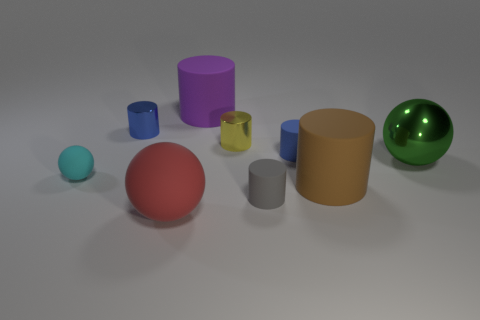What material is the big object that is behind the green thing?
Offer a very short reply. Rubber. Is the purple thing the same size as the brown matte object?
Ensure brevity in your answer.  Yes. Are there more large balls that are on the left side of the green metal sphere than big yellow cylinders?
Your answer should be compact. Yes. There is a cyan sphere that is made of the same material as the purple cylinder; what is its size?
Provide a short and direct response. Small. There is a tiny yellow thing; are there any blue cylinders to the left of it?
Give a very brief answer. Yes. Is the shape of the purple rubber thing the same as the yellow thing?
Your answer should be very brief. Yes. There is a matte sphere on the right side of the metallic cylinder that is to the left of the matte cylinder behind the small yellow cylinder; what size is it?
Your answer should be compact. Large. What is the yellow cylinder made of?
Your answer should be compact. Metal. There is a tiny yellow object; does it have the same shape as the large matte object behind the small matte sphere?
Provide a succinct answer. Yes. There is a small cylinder to the left of the small metal cylinder to the right of the big cylinder that is behind the blue metallic cylinder; what is it made of?
Ensure brevity in your answer.  Metal. 